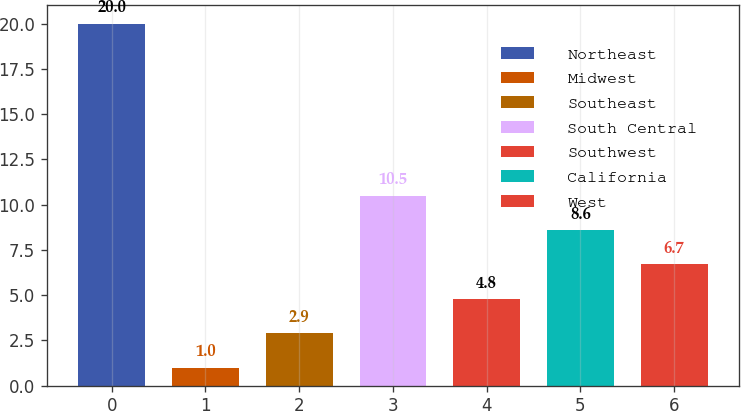<chart> <loc_0><loc_0><loc_500><loc_500><bar_chart><fcel>Northeast<fcel>Midwest<fcel>Southeast<fcel>South Central<fcel>Southwest<fcel>California<fcel>West<nl><fcel>20<fcel>1<fcel>2.9<fcel>10.5<fcel>4.8<fcel>8.6<fcel>6.7<nl></chart> 